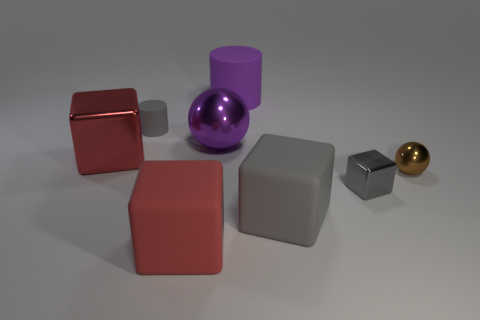Is the color of the large sphere the same as the large matte cylinder?
Your answer should be very brief. Yes. Is the shape of the big red shiny thing the same as the small gray metallic thing?
Your response must be concise. Yes. There is a metallic sphere that is on the right side of the big purple cylinder; is it the same size as the gray rubber thing behind the tiny gray metallic block?
Ensure brevity in your answer.  Yes. There is a big object that is both right of the red rubber cube and in front of the purple ball; what is its material?
Provide a succinct answer. Rubber. Is there any other thing that is the same color as the small shiny sphere?
Make the answer very short. No. Is the number of gray metallic cubes behind the small brown metal sphere less than the number of big blue rubber cylinders?
Your response must be concise. No. Is the number of tiny gray metallic cylinders greater than the number of purple rubber cylinders?
Offer a very short reply. No. There is a gray object that is on the left side of the shiny thing behind the big red shiny object; are there any small matte things behind it?
Offer a terse response. No. What number of other things are the same size as the purple shiny ball?
Make the answer very short. 4. Are there any red objects on the left side of the red rubber thing?
Give a very brief answer. Yes. 